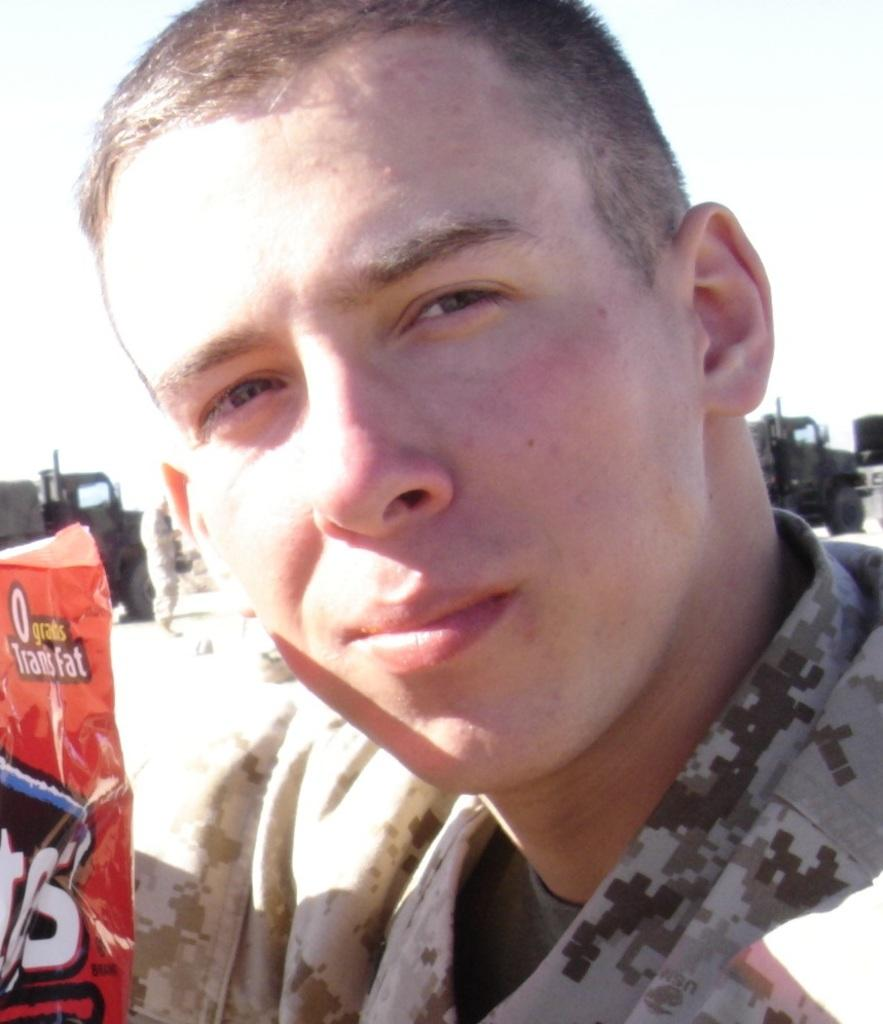Who is present in the image? There is a man in the image. What is located on the left side of the image? There is a cover on the left side of the image. What can be seen in the background of the image? There are vehicles in the background of the image. What is the person in the image standing on? The person is standing on the ground in the image. What is visible in the sky in the image? The sky is visible in the image. What type of ornament is hanging from the engine in the image? There is no engine or ornament present in the image. 